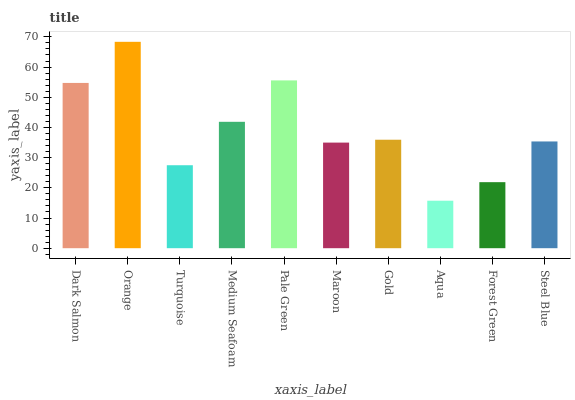Is Turquoise the minimum?
Answer yes or no. No. Is Turquoise the maximum?
Answer yes or no. No. Is Orange greater than Turquoise?
Answer yes or no. Yes. Is Turquoise less than Orange?
Answer yes or no. Yes. Is Turquoise greater than Orange?
Answer yes or no. No. Is Orange less than Turquoise?
Answer yes or no. No. Is Gold the high median?
Answer yes or no. Yes. Is Steel Blue the low median?
Answer yes or no. Yes. Is Dark Salmon the high median?
Answer yes or no. No. Is Orange the low median?
Answer yes or no. No. 